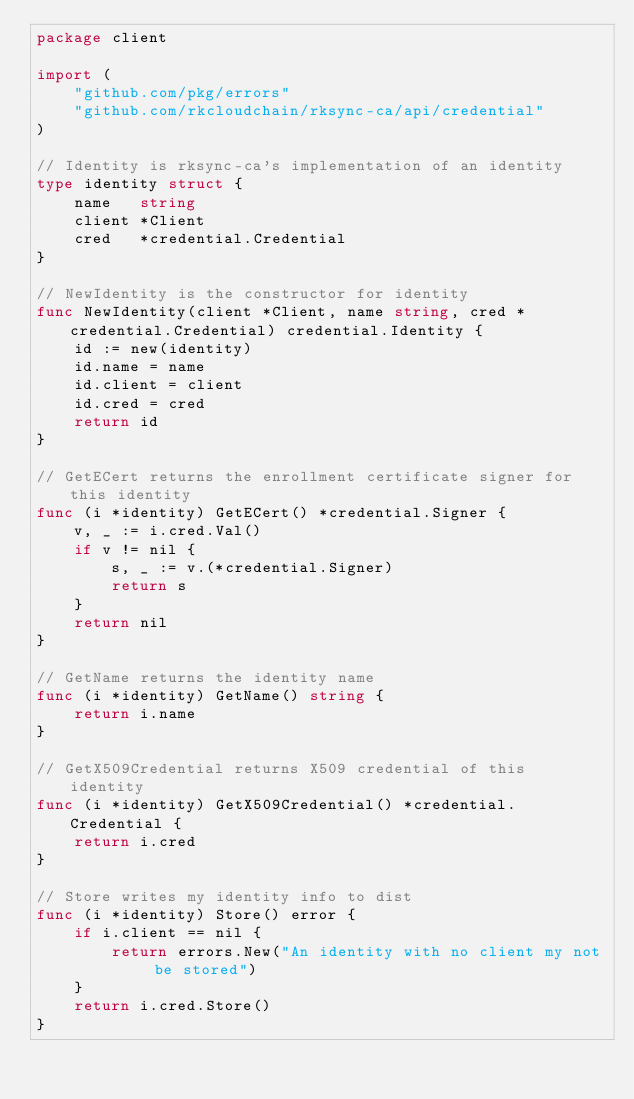Convert code to text. <code><loc_0><loc_0><loc_500><loc_500><_Go_>package client

import (
	"github.com/pkg/errors"
	"github.com/rkcloudchain/rksync-ca/api/credential"
)

// Identity is rksync-ca's implementation of an identity
type identity struct {
	name   string
	client *Client
	cred   *credential.Credential
}

// NewIdentity is the constructor for identity
func NewIdentity(client *Client, name string, cred *credential.Credential) credential.Identity {
	id := new(identity)
	id.name = name
	id.client = client
	id.cred = cred
	return id
}

// GetECert returns the enrollment certificate signer for this identity
func (i *identity) GetECert() *credential.Signer {
	v, _ := i.cred.Val()
	if v != nil {
		s, _ := v.(*credential.Signer)
		return s
	}
	return nil
}

// GetName returns the identity name
func (i *identity) GetName() string {
	return i.name
}

// GetX509Credential returns X509 credential of this identity
func (i *identity) GetX509Credential() *credential.Credential {
	return i.cred
}

// Store writes my identity info to dist
func (i *identity) Store() error {
	if i.client == nil {
		return errors.New("An identity with no client my not be stored")
	}
	return i.cred.Store()
}
</code> 